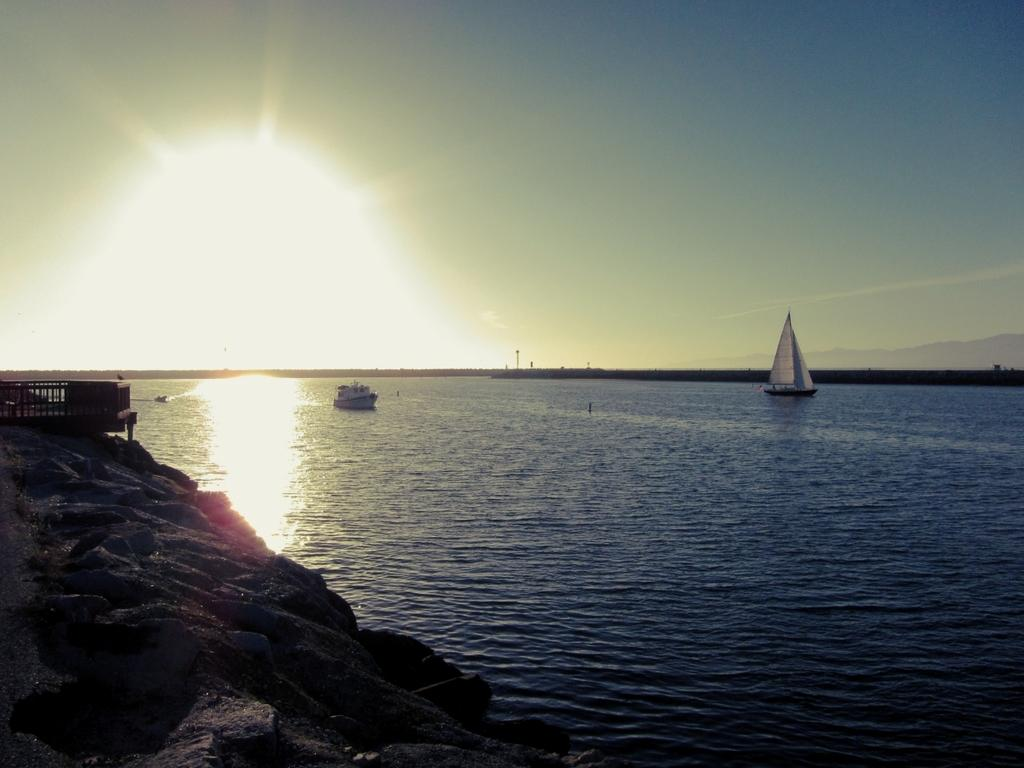What is happening in the main part of the image? There are boats sailing on the water in the image. Where are the boats located in relation to the image? The boats are in the center of the image. What structure can be seen on the left side of the image? There is a bridge on the left side of the image. What objects are on the right side of the image? There are poles on the right side of the image. What type of alley can be seen behind the bridge in the image? There is no alley present in the image; it features boats sailing on the water, a bridge on the left side, and poles on the right side. 